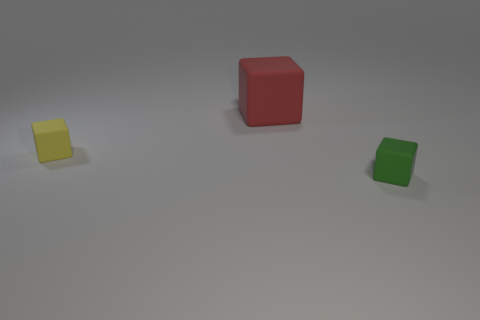How many objects are both behind the small green cube and right of the tiny yellow matte object?
Provide a succinct answer. 1. There is a cube that is to the left of the red rubber block; what is it made of?
Offer a terse response. Rubber. What is the size of the red thing that is the same material as the green object?
Your answer should be very brief. Large. Are there any green objects on the left side of the large rubber object?
Your answer should be very brief. No. What is the size of the green object that is the same shape as the large red object?
Make the answer very short. Small. Do the large block and the small block that is in front of the yellow matte thing have the same color?
Keep it short and to the point. No. Are there fewer big matte cubes than small rubber things?
Make the answer very short. Yes. How many big red cubes are there?
Offer a very short reply. 1. Is the number of yellow cubes that are to the right of the big rubber cube less than the number of rubber balls?
Ensure brevity in your answer.  No. Is the material of the object to the left of the big red rubber object the same as the red object?
Offer a very short reply. Yes. 